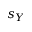Convert formula to latex. <formula><loc_0><loc_0><loc_500><loc_500>s _ { Y }</formula> 